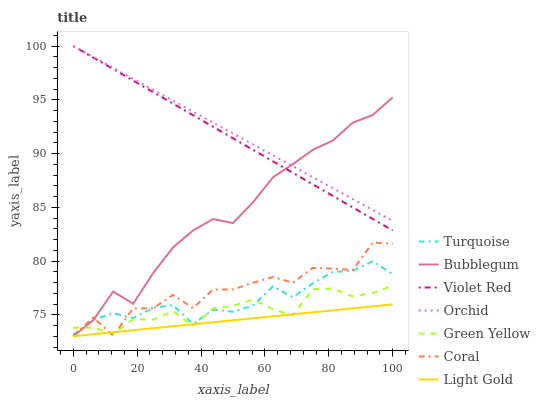Does Light Gold have the minimum area under the curve?
Answer yes or no. Yes. Does Orchid have the maximum area under the curve?
Answer yes or no. Yes. Does Coral have the minimum area under the curve?
Answer yes or no. No. Does Coral have the maximum area under the curve?
Answer yes or no. No. Is Violet Red the smoothest?
Answer yes or no. Yes. Is Coral the roughest?
Answer yes or no. Yes. Is Coral the smoothest?
Answer yes or no. No. Is Violet Red the roughest?
Answer yes or no. No. Does Coral have the lowest value?
Answer yes or no. Yes. Does Violet Red have the lowest value?
Answer yes or no. No. Does Orchid have the highest value?
Answer yes or no. Yes. Does Coral have the highest value?
Answer yes or no. No. Is Light Gold less than Bubblegum?
Answer yes or no. Yes. Is Orchid greater than Turquoise?
Answer yes or no. Yes. Does Orchid intersect Bubblegum?
Answer yes or no. Yes. Is Orchid less than Bubblegum?
Answer yes or no. No. Is Orchid greater than Bubblegum?
Answer yes or no. No. Does Light Gold intersect Bubblegum?
Answer yes or no. No. 